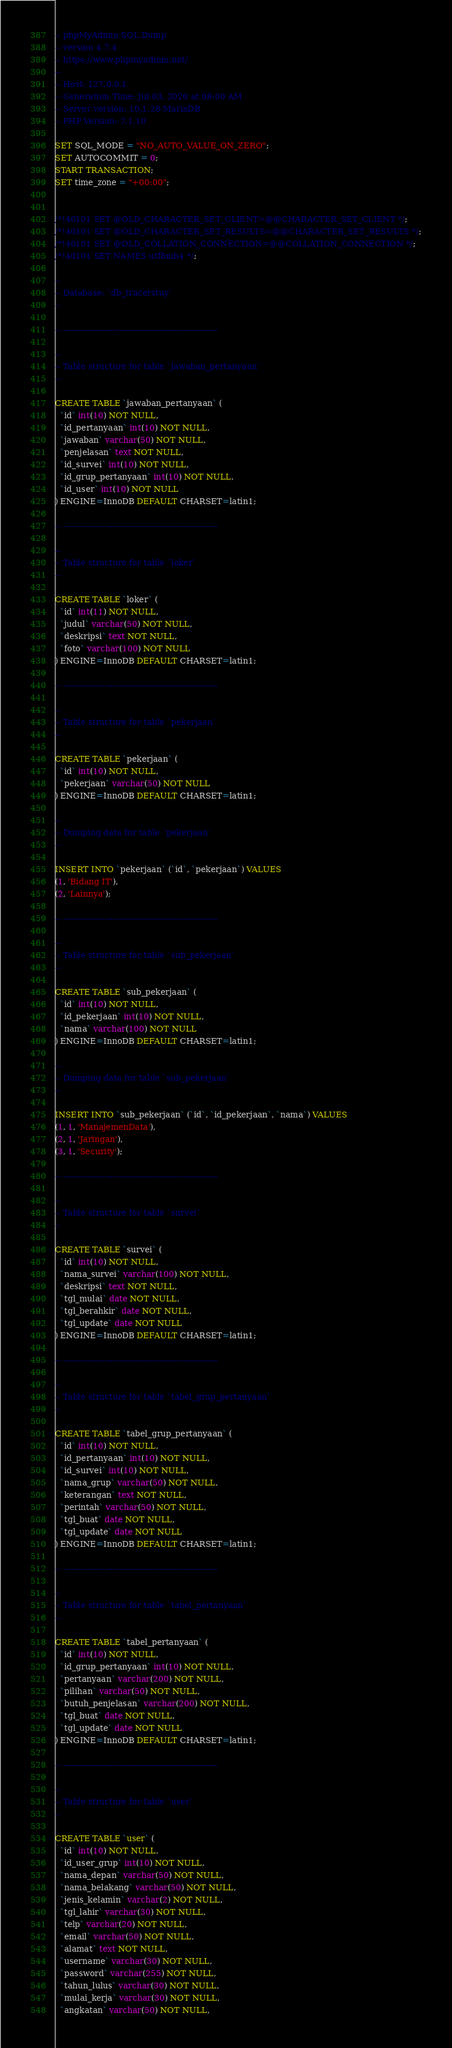<code> <loc_0><loc_0><loc_500><loc_500><_SQL_>-- phpMyAdmin SQL Dump
-- version 4.7.4
-- https://www.phpmyadmin.net/
--
-- Host: 127.0.0.1
-- Generation Time: Jul 03, 2020 at 08:00 AM
-- Server version: 10.1.28-MariaDB
-- PHP Version: 7.1.10

SET SQL_MODE = "NO_AUTO_VALUE_ON_ZERO";
SET AUTOCOMMIT = 0;
START TRANSACTION;
SET time_zone = "+00:00";


/*!40101 SET @OLD_CHARACTER_SET_CLIENT=@@CHARACTER_SET_CLIENT */;
/*!40101 SET @OLD_CHARACTER_SET_RESULTS=@@CHARACTER_SET_RESULTS */;
/*!40101 SET @OLD_COLLATION_CONNECTION=@@COLLATION_CONNECTION */;
/*!40101 SET NAMES utf8mb4 */;

--
-- Database: `db_tracerstuy`
--

-- --------------------------------------------------------

--
-- Table structure for table `jawaban_pertanyaan`
--

CREATE TABLE `jawaban_pertanyaan` (
  `id` int(10) NOT NULL,
  `id_pertanyaan` int(10) NOT NULL,
  `jawaban` varchar(50) NOT NULL,
  `penjelasan` text NOT NULL,
  `id_survei` int(10) NOT NULL,
  `id_grup_pertanyaan` int(10) NOT NULL,
  `id_user` int(10) NOT NULL
) ENGINE=InnoDB DEFAULT CHARSET=latin1;

-- --------------------------------------------------------

--
-- Table structure for table `loker`
--

CREATE TABLE `loker` (
  `id` int(11) NOT NULL,
  `judul` varchar(50) NOT NULL,
  `deskripsi` text NOT NULL,
  `foto` varchar(100) NOT NULL
) ENGINE=InnoDB DEFAULT CHARSET=latin1;

-- --------------------------------------------------------

--
-- Table structure for table `pekerjaan`
--

CREATE TABLE `pekerjaan` (
  `id` int(10) NOT NULL,
  `pekerjaan` varchar(50) NOT NULL
) ENGINE=InnoDB DEFAULT CHARSET=latin1;

--
-- Dumping data for table `pekerjaan`
--

INSERT INTO `pekerjaan` (`id`, `pekerjaan`) VALUES
(1, 'Bidang IT'),
(2, 'Lainnya');

-- --------------------------------------------------------

--
-- Table structure for table `sub_pekerjaan`
--

CREATE TABLE `sub_pekerjaan` (
  `id` int(10) NOT NULL,
  `id_pekerjaan` int(10) NOT NULL,
  `nama` varchar(100) NOT NULL
) ENGINE=InnoDB DEFAULT CHARSET=latin1;

--
-- Dumping data for table `sub_pekerjaan`
--

INSERT INTO `sub_pekerjaan` (`id`, `id_pekerjaan`, `nama`) VALUES
(1, 1, 'ManajemenData'),
(2, 1, 'Jaringan'),
(3, 1, 'Security');

-- --------------------------------------------------------

--
-- Table structure for table `survei`
--

CREATE TABLE `survei` (
  `id` int(10) NOT NULL,
  `nama_survei` varchar(100) NOT NULL,
  `deskripsi` text NOT NULL,
  `tgl_mulai` date NOT NULL,
  `tgl_berahkir` date NOT NULL,
  `tgl_update` date NOT NULL
) ENGINE=InnoDB DEFAULT CHARSET=latin1;

-- --------------------------------------------------------

--
-- Table structure for table `tabel_grup_pertanyaan`
--

CREATE TABLE `tabel_grup_pertanyaan` (
  `id` int(10) NOT NULL,
  `id_pertanyaan` int(10) NOT NULL,
  `id_survei` int(10) NOT NULL,
  `nama_grup` varchar(50) NOT NULL,
  `keterangan` text NOT NULL,
  `perintah` varchar(50) NOT NULL,
  `tgl_buat` date NOT NULL,
  `tgl_update` date NOT NULL
) ENGINE=InnoDB DEFAULT CHARSET=latin1;

-- --------------------------------------------------------

--
-- Table structure for table `tabel_pertanyaan`
--

CREATE TABLE `tabel_pertanyaan` (
  `id` int(10) NOT NULL,
  `id_grup_pertanyaan` int(10) NOT NULL,
  `pertanyaan` varchar(200) NOT NULL,
  `pilihan` varchar(50) NOT NULL,
  `butuh_penjelasan` varchar(200) NOT NULL,
  `tgl_buat` date NOT NULL,
  `tgl_update` date NOT NULL
) ENGINE=InnoDB DEFAULT CHARSET=latin1;

-- --------------------------------------------------------

--
-- Table structure for table `user`
--

CREATE TABLE `user` (
  `id` int(10) NOT NULL,
  `id_user_grup` int(10) NOT NULL,
  `nama_depan` varchar(50) NOT NULL,
  `nama_belakang` varchar(50) NOT NULL,
  `jenis_kelamin` varchar(2) NOT NULL,
  `tgl_lahir` varchar(30) NOT NULL,
  `telp` varchar(20) NOT NULL,
  `email` varchar(50) NOT NULL,
  `alamat` text NOT NULL,
  `username` varchar(30) NOT NULL,
  `password` varchar(255) NOT NULL,
  `tahun_lulus` varchar(30) NOT NULL,
  `mulai_kerja` varchar(30) NOT NULL,
  `angkatan` varchar(50) NOT NULL,</code> 